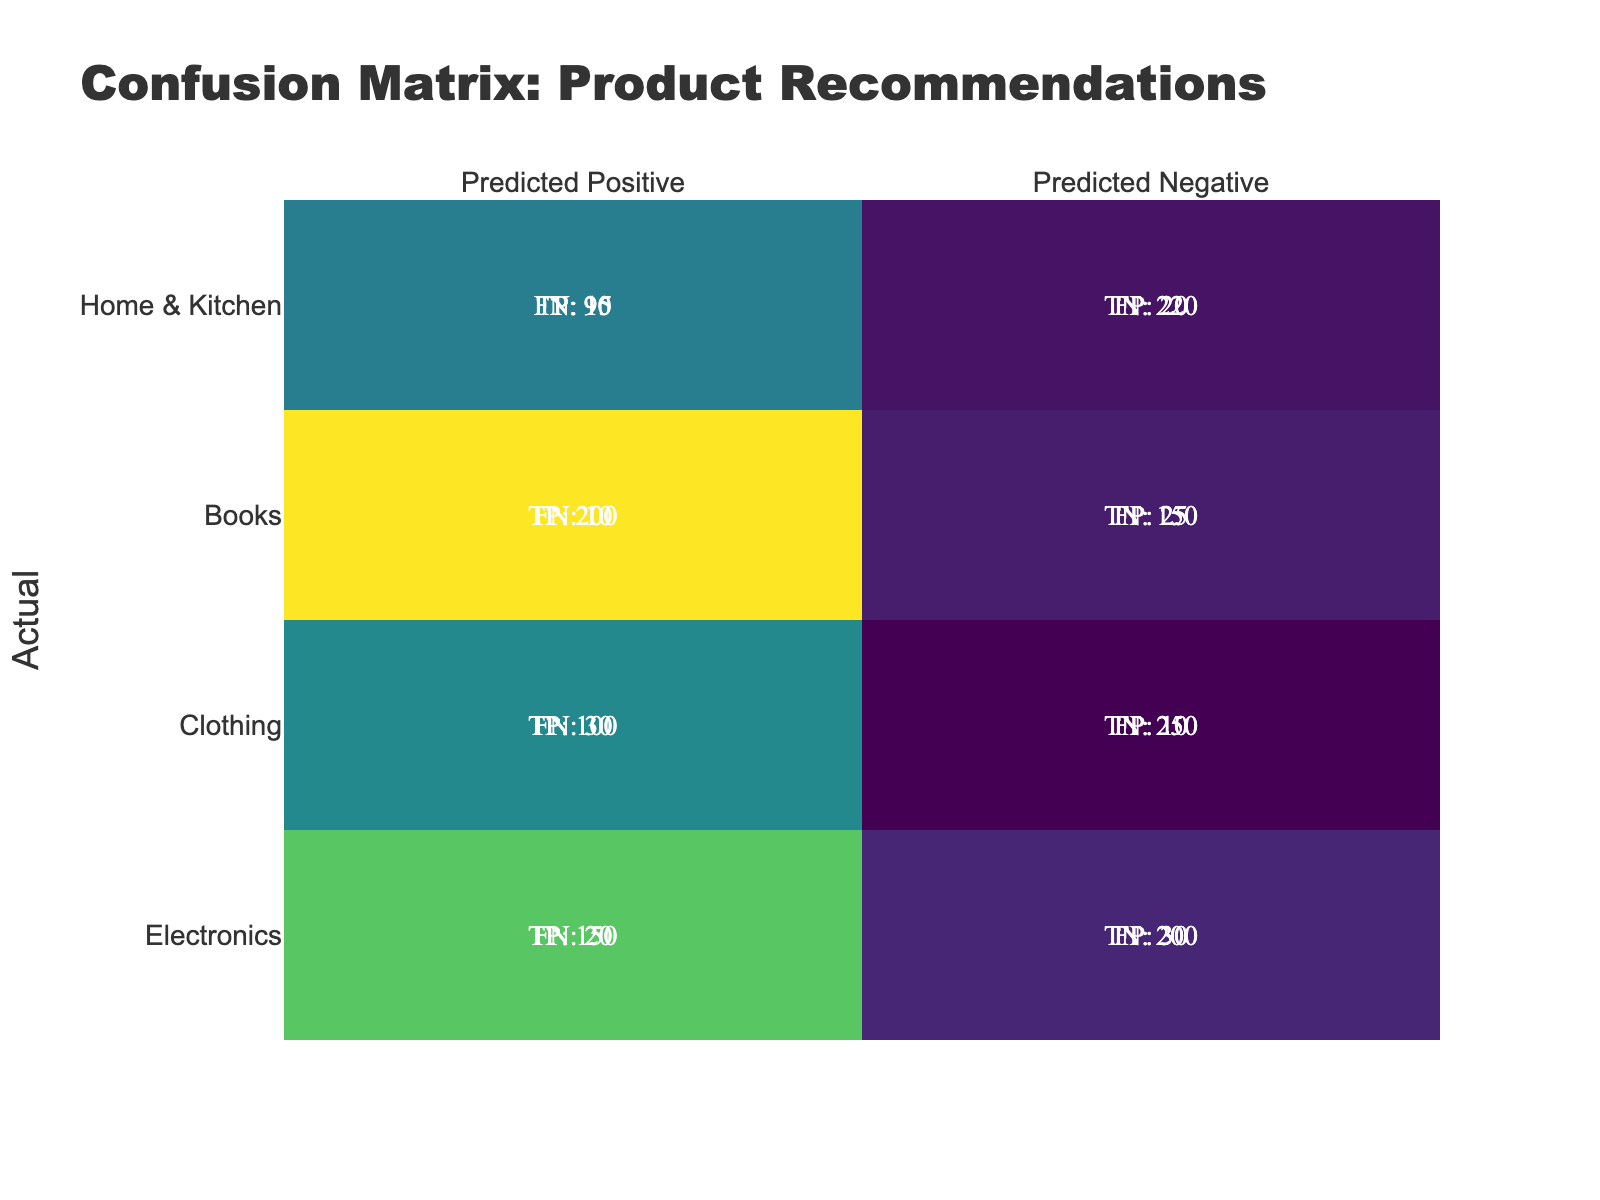What is the True Positive for the Fiction book? The True Positive (TP) for Fiction is directly listed in the table under the Fiction category. Therefore, the value is 200.
Answer: 200 What is the total number of True Negatives across all categories? To find the total True Negatives (TN), I sum the TN values for all categories: 200 (Electronics, Smartphone) + 180 (Electronics, Laptop) + 250 (Clothing, T-shirt) + 270 (Clothing, Jacket) + 150 (Books, Fiction) + 200 (Books, Non-Fiction) + 220 (Home & Kitchen, Blender) + 210 (Home & Kitchen, Microwave) = 1980.
Answer: 1980 Is there a higher number of False Positives for Clothing or Home & Kitchen? To determine this, I look at the False Positive (FP) values for each category. Clothing has 10 (T-shirt) + 5 (Jacket) = 15 total FP, while Home & Kitchen has 20 (Blender) + 15 (Microwave) = 35 total FP. Since 35 is greater than 15, the answer is yes.
Answer: Yes What is the difference between True Positives and False Negatives for the Laptop recommendation? For the Laptop recommendation, the True Positive is 120 and the False Negative is 25. The difference is calculated as 120 - 25 = 95.
Answer: 95 What is the average number of True Positives across all categories? To find the average True Positives, I sum up all the True Positive values: 150 (Smartphone) + 120 (Laptop) + 100 (T-shirt) + 80 (Jacket) + 200 (Fiction) + 150 (Non-Fiction) + 90 (Blender) + 110 (Microwave) = 1100. Then, I divide by the number of categories, which is 8. So, the average is 1100 / 8 = 137.5.
Answer: 137.5 